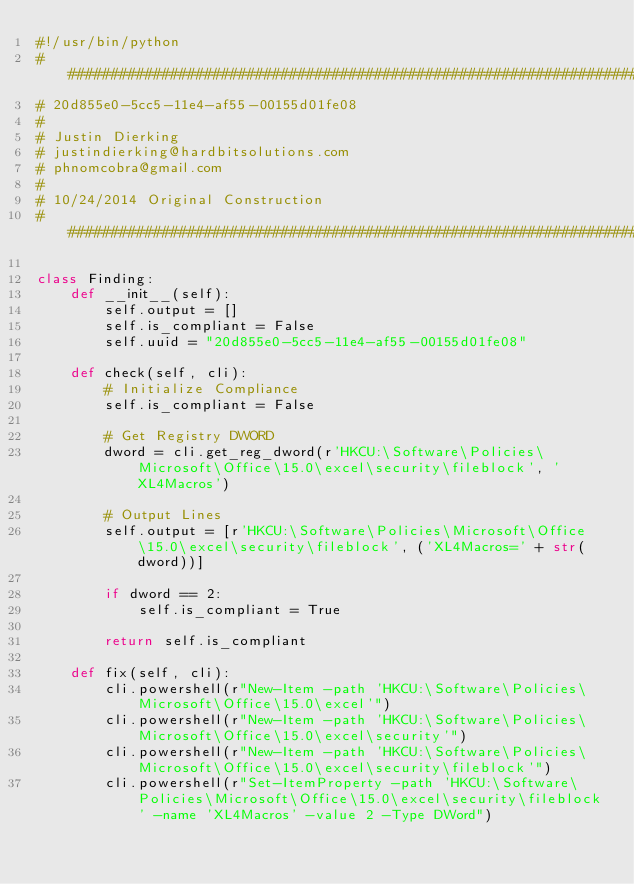<code> <loc_0><loc_0><loc_500><loc_500><_Python_>#!/usr/bin/python
################################################################################
# 20d855e0-5cc5-11e4-af55-00155d01fe08
#
# Justin Dierking
# justindierking@hardbitsolutions.com
# phnomcobra@gmail.com
#
# 10/24/2014 Original Construction
################################################################################

class Finding:
    def __init__(self):
        self.output = []
        self.is_compliant = False
        self.uuid = "20d855e0-5cc5-11e4-af55-00155d01fe08"
        
    def check(self, cli):
        # Initialize Compliance
        self.is_compliant = False

        # Get Registry DWORD
        dword = cli.get_reg_dword(r'HKCU:\Software\Policies\Microsoft\Office\15.0\excel\security\fileblock', 'XL4Macros')

        # Output Lines
        self.output = [r'HKCU:\Software\Policies\Microsoft\Office\15.0\excel\security\fileblock', ('XL4Macros=' + str(dword))]

        if dword == 2:
            self.is_compliant = True

        return self.is_compliant

    def fix(self, cli):
        cli.powershell(r"New-Item -path 'HKCU:\Software\Policies\Microsoft\Office\15.0\excel'")
        cli.powershell(r"New-Item -path 'HKCU:\Software\Policies\Microsoft\Office\15.0\excel\security'")
        cli.powershell(r"New-Item -path 'HKCU:\Software\Policies\Microsoft\Office\15.0\excel\security\fileblock'")
        cli.powershell(r"Set-ItemProperty -path 'HKCU:\Software\Policies\Microsoft\Office\15.0\excel\security\fileblock' -name 'XL4Macros' -value 2 -Type DWord")
</code> 